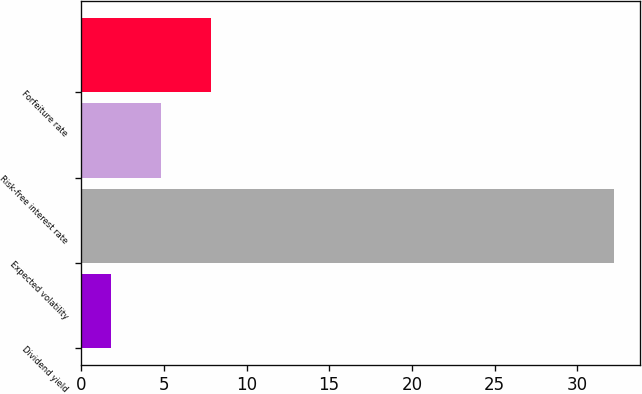Convert chart to OTSL. <chart><loc_0><loc_0><loc_500><loc_500><bar_chart><fcel>Dividend yield<fcel>Expected volatility<fcel>Risk-free interest rate<fcel>Forfeiture rate<nl><fcel>1.8<fcel>32.2<fcel>4.84<fcel>7.88<nl></chart> 